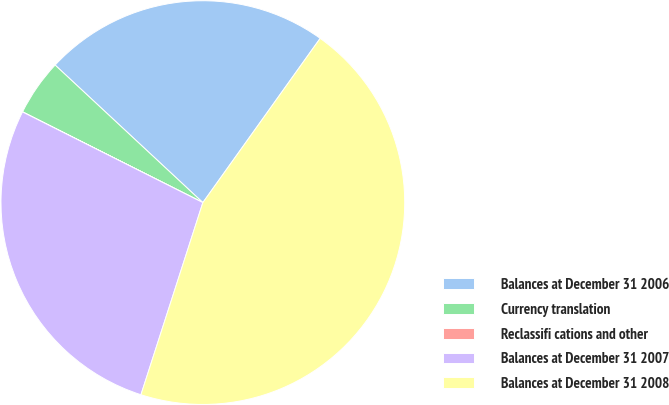Convert chart. <chart><loc_0><loc_0><loc_500><loc_500><pie_chart><fcel>Balances at December 31 2006<fcel>Currency translation<fcel>Reclassifi cations and other<fcel>Balances at December 31 2007<fcel>Balances at December 31 2008<nl><fcel>22.94%<fcel>4.51%<fcel>0.01%<fcel>27.45%<fcel>45.09%<nl></chart> 